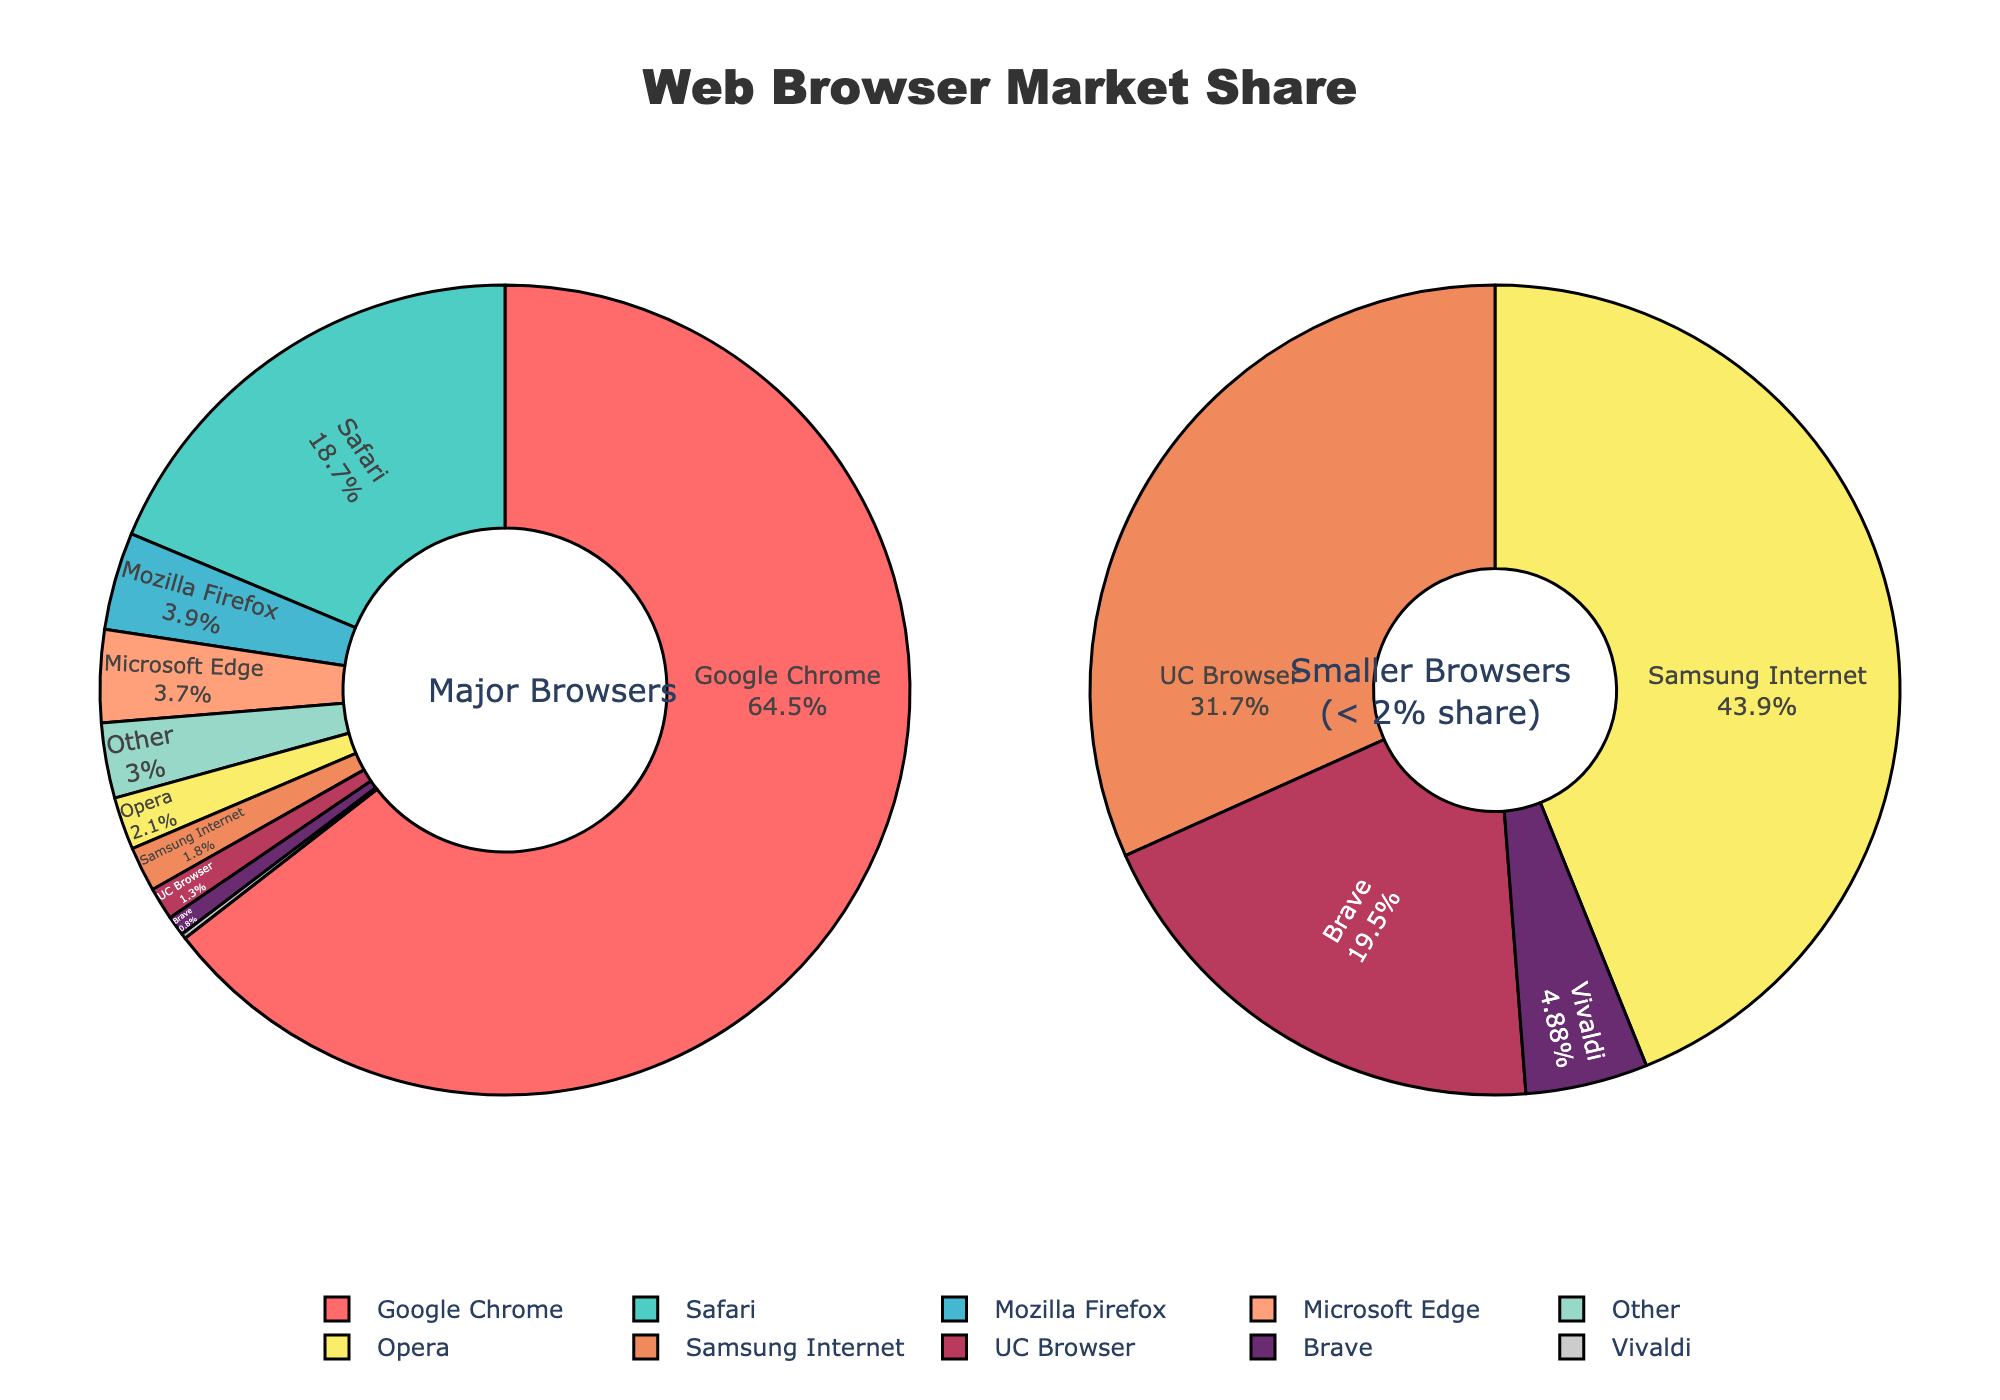Which browser has the largest market share? The largest market share can be determined by looking for the biggest section in the main pie chart or identifying the browser with the highest percentage next to its label. Google Chrome has the largest section in the main pie chart.
Answer: Google Chrome What's the total market share of browsers with less than 2% share? To calculate the total share of these browsers, look at the smaller pie chart that specifically labels browsers with less than 2% market share and sum their percentages: Opera (2.1), Samsung Internet (1.8), UC Browser (1.3), Brave (0.8), and Vivaldi (0.2). 1.8 + 1.3 + 0.8 + 0.2 = 4.1%
Answer: 6.2% How many browsers have a market share greater than 10%? This can be deduced by scanning the labels in the main pie chart and counting how many browsers have their market share percentage labeled as greater than 10%. Only Google Chrome (64.5%) and Safari (18.7%) have shares greater than 10%.
Answer: 2 Which browsers have almost equal market shares, differing by no more than 0.2%? Compare the percentages labeled in the main pie chart. Microsoft Edge (3.7%) and Mozilla Firefox (3.9%) differ by 0.2%, making them the closest in market share.
Answer: Microsoft Edge and Mozilla Firefox Is the market share of 'Opera' larger than 'Other' browsers combined? Check the labels in the main pie chart for 'Opera' and 'Other'. Opera has a 2.1% share while Other browsers combined are 3.0%. Comparative analysis shows 'Other' browsers combined have a larger share.
Answer: No What's the combined market share of Google Chrome and Mozilla Firefox? Sum the market shares of Google Chrome (64.5%) and Mozilla Firefox (3.9%). 64.5 + 3.9 = 68.4%
Answer: 68.4% Which browser has the smallest market share? Notice the smallest segment in the smaller pie chart which represents browsers with market shares below 2%. Vivaldi has the smallest market share of 0.2%.
Answer: Vivaldi 